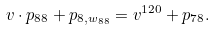<formula> <loc_0><loc_0><loc_500><loc_500>& v \cdot p _ { 8 8 } + p _ { 8 , w _ { 8 8 } } = v ^ { 1 2 0 } + p _ { 7 8 } .</formula> 